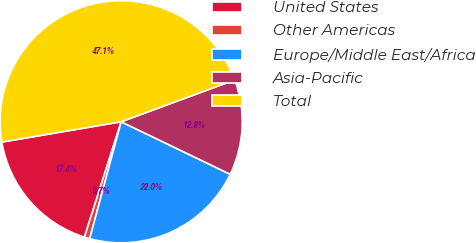<chart> <loc_0><loc_0><loc_500><loc_500><pie_chart><fcel>United States<fcel>Other Americas<fcel>Europe/Middle East/Africa<fcel>Asia-Pacific<fcel>Total<nl><fcel>17.41%<fcel>0.72%<fcel>22.04%<fcel>12.77%<fcel>47.06%<nl></chart> 